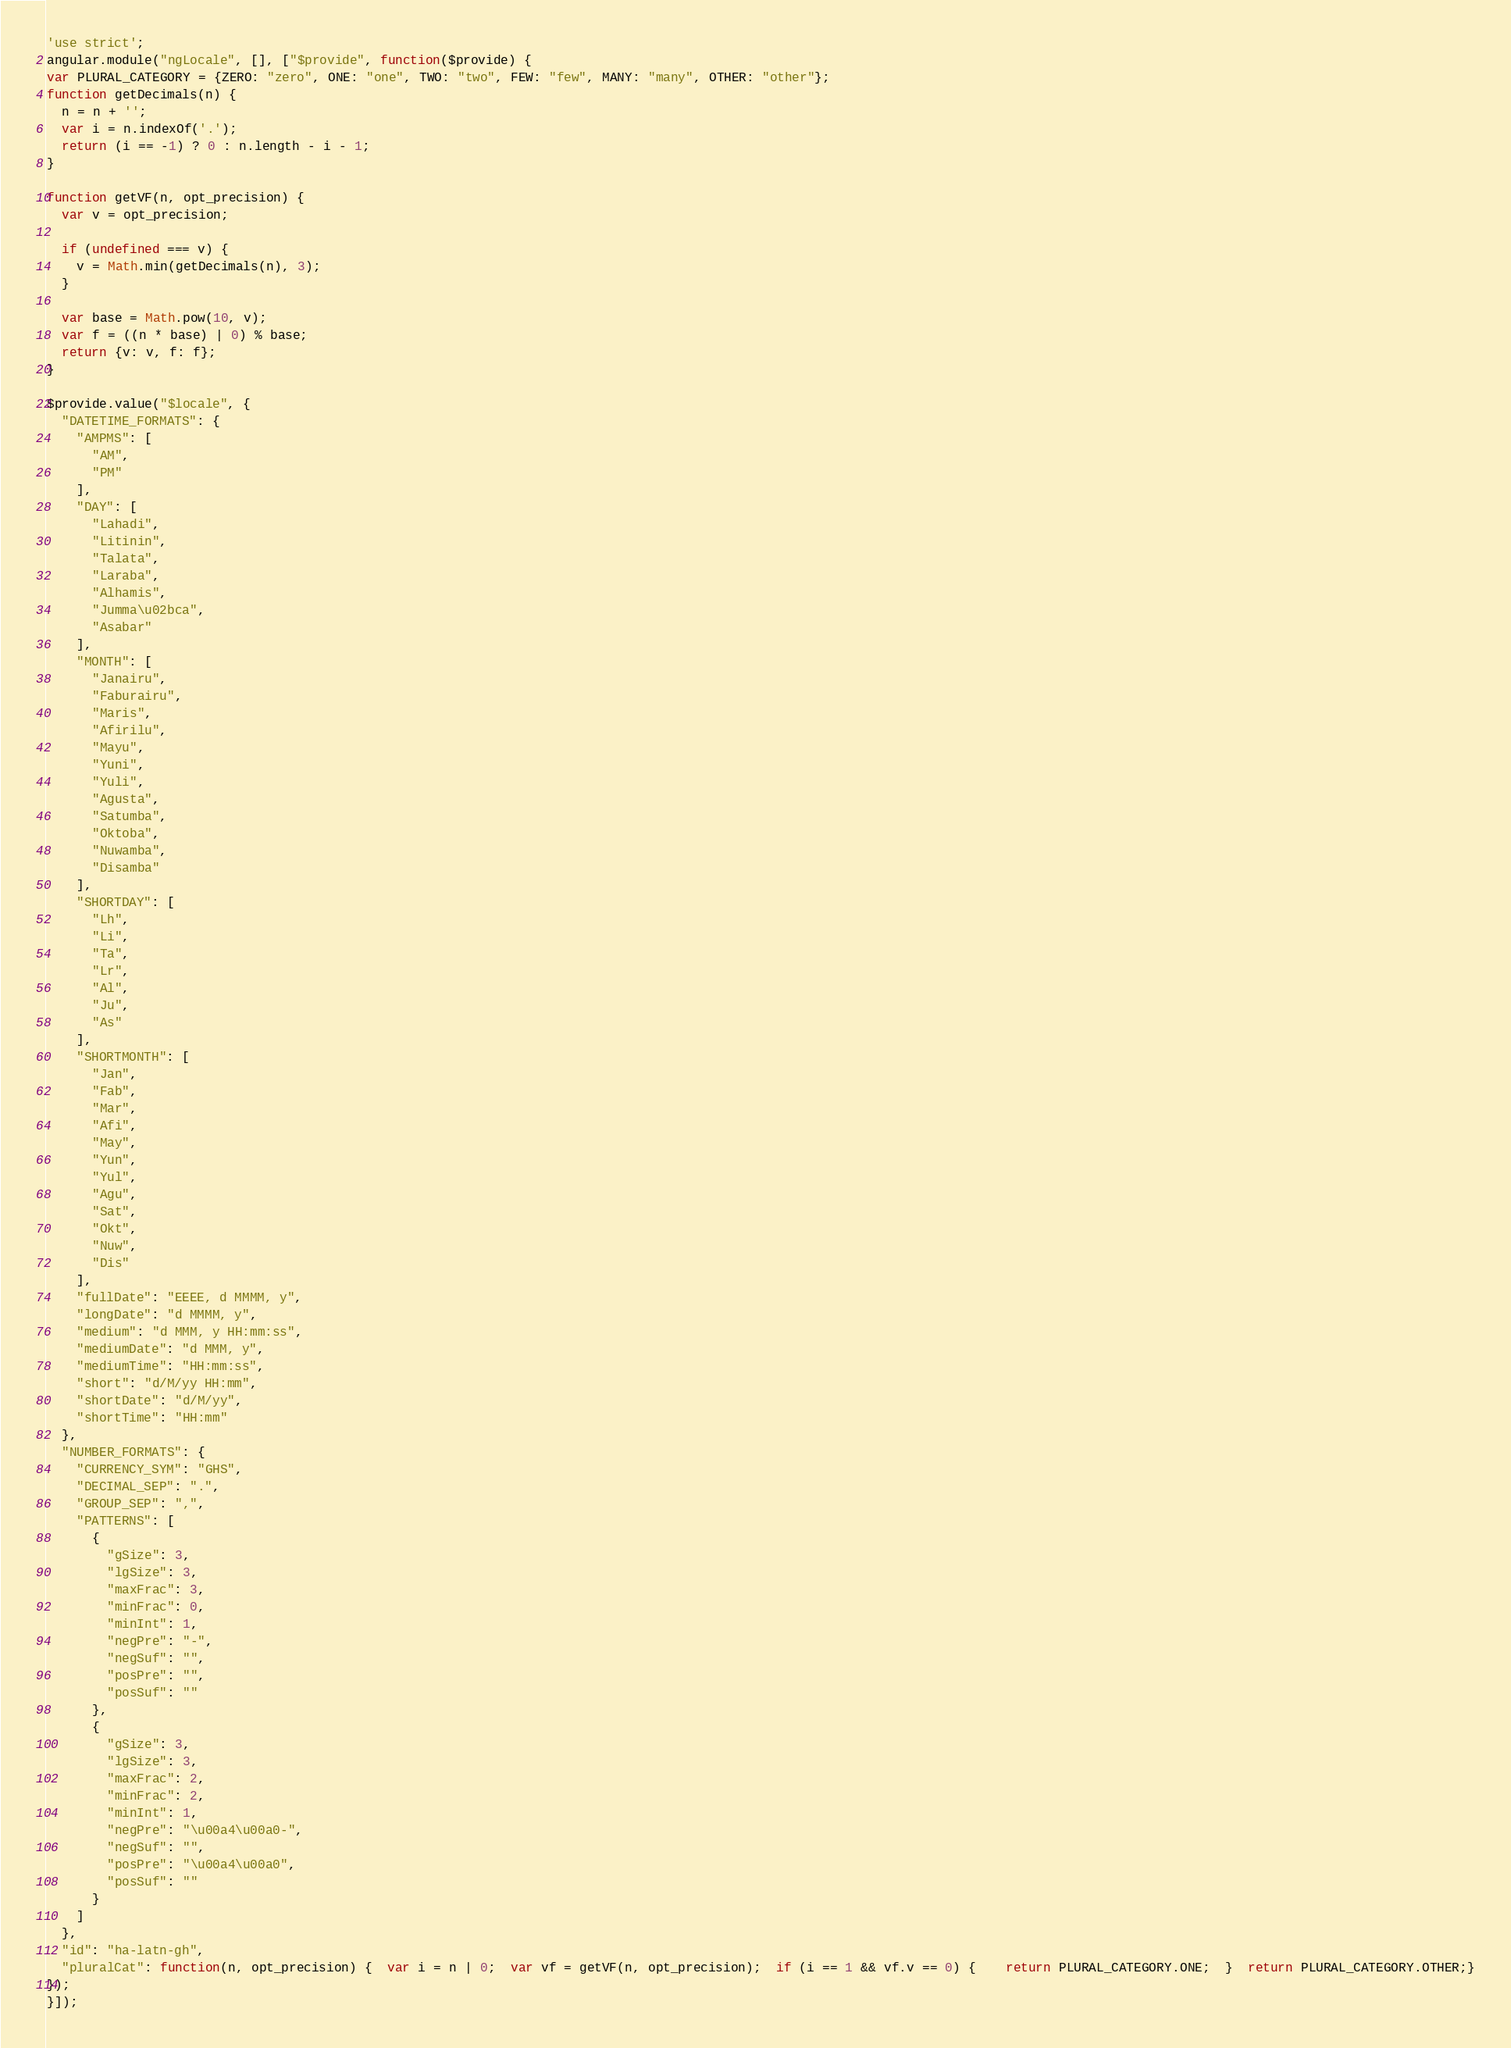Convert code to text. <code><loc_0><loc_0><loc_500><loc_500><_JavaScript_>'use strict';
angular.module("ngLocale", [], ["$provide", function($provide) {
var PLURAL_CATEGORY = {ZERO: "zero", ONE: "one", TWO: "two", FEW: "few", MANY: "many", OTHER: "other"};
function getDecimals(n) {
  n = n + '';
  var i = n.indexOf('.');
  return (i == -1) ? 0 : n.length - i - 1;
}

function getVF(n, opt_precision) {
  var v = opt_precision;

  if (undefined === v) {
    v = Math.min(getDecimals(n), 3);
  }

  var base = Math.pow(10, v);
  var f = ((n * base) | 0) % base;
  return {v: v, f: f};
}

$provide.value("$locale", {
  "DATETIME_FORMATS": {
    "AMPMS": [
      "AM",
      "PM"
    ],
    "DAY": [
      "Lahadi",
      "Litinin",
      "Talata",
      "Laraba",
      "Alhamis",
      "Jumma\u02bca",
      "Asabar"
    ],
    "MONTH": [
      "Janairu",
      "Faburairu",
      "Maris",
      "Afirilu",
      "Mayu",
      "Yuni",
      "Yuli",
      "Agusta",
      "Satumba",
      "Oktoba",
      "Nuwamba",
      "Disamba"
    ],
    "SHORTDAY": [
      "Lh",
      "Li",
      "Ta",
      "Lr",
      "Al",
      "Ju",
      "As"
    ],
    "SHORTMONTH": [
      "Jan",
      "Fab",
      "Mar",
      "Afi",
      "May",
      "Yun",
      "Yul",
      "Agu",
      "Sat",
      "Okt",
      "Nuw",
      "Dis"
    ],
    "fullDate": "EEEE, d MMMM, y",
    "longDate": "d MMMM, y",
    "medium": "d MMM, y HH:mm:ss",
    "mediumDate": "d MMM, y",
    "mediumTime": "HH:mm:ss",
    "short": "d/M/yy HH:mm",
    "shortDate": "d/M/yy",
    "shortTime": "HH:mm"
  },
  "NUMBER_FORMATS": {
    "CURRENCY_SYM": "GHS",
    "DECIMAL_SEP": ".",
    "GROUP_SEP": ",",
    "PATTERNS": [
      {
        "gSize": 3,
        "lgSize": 3,
        "maxFrac": 3,
        "minFrac": 0,
        "minInt": 1,
        "negPre": "-",
        "negSuf": "",
        "posPre": "",
        "posSuf": ""
      },
      {
        "gSize": 3,
        "lgSize": 3,
        "maxFrac": 2,
        "minFrac": 2,
        "minInt": 1,
        "negPre": "\u00a4\u00a0-",
        "negSuf": "",
        "posPre": "\u00a4\u00a0",
        "posSuf": ""
      }
    ]
  },
  "id": "ha-latn-gh",
  "pluralCat": function(n, opt_precision) {  var i = n | 0;  var vf = getVF(n, opt_precision);  if (i == 1 && vf.v == 0) {    return PLURAL_CATEGORY.ONE;  }  return PLURAL_CATEGORY.OTHER;}
});
}]);
</code> 